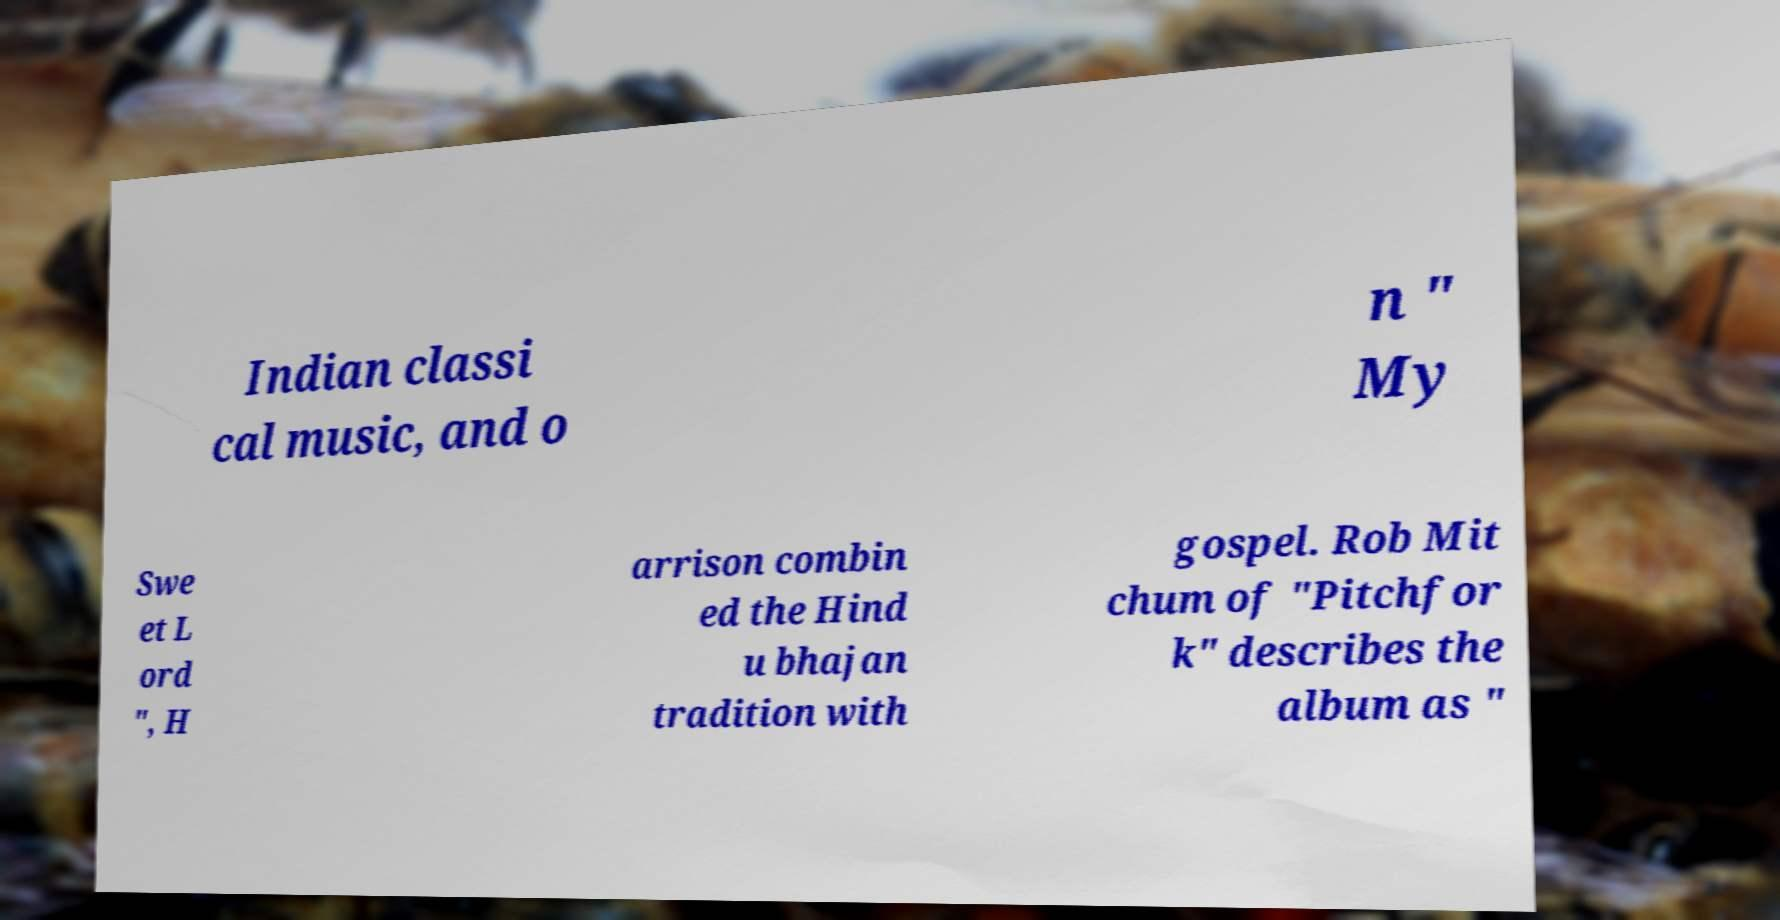Please read and relay the text visible in this image. What does it say? Indian classi cal music, and o n " My Swe et L ord ", H arrison combin ed the Hind u bhajan tradition with gospel. Rob Mit chum of "Pitchfor k" describes the album as " 